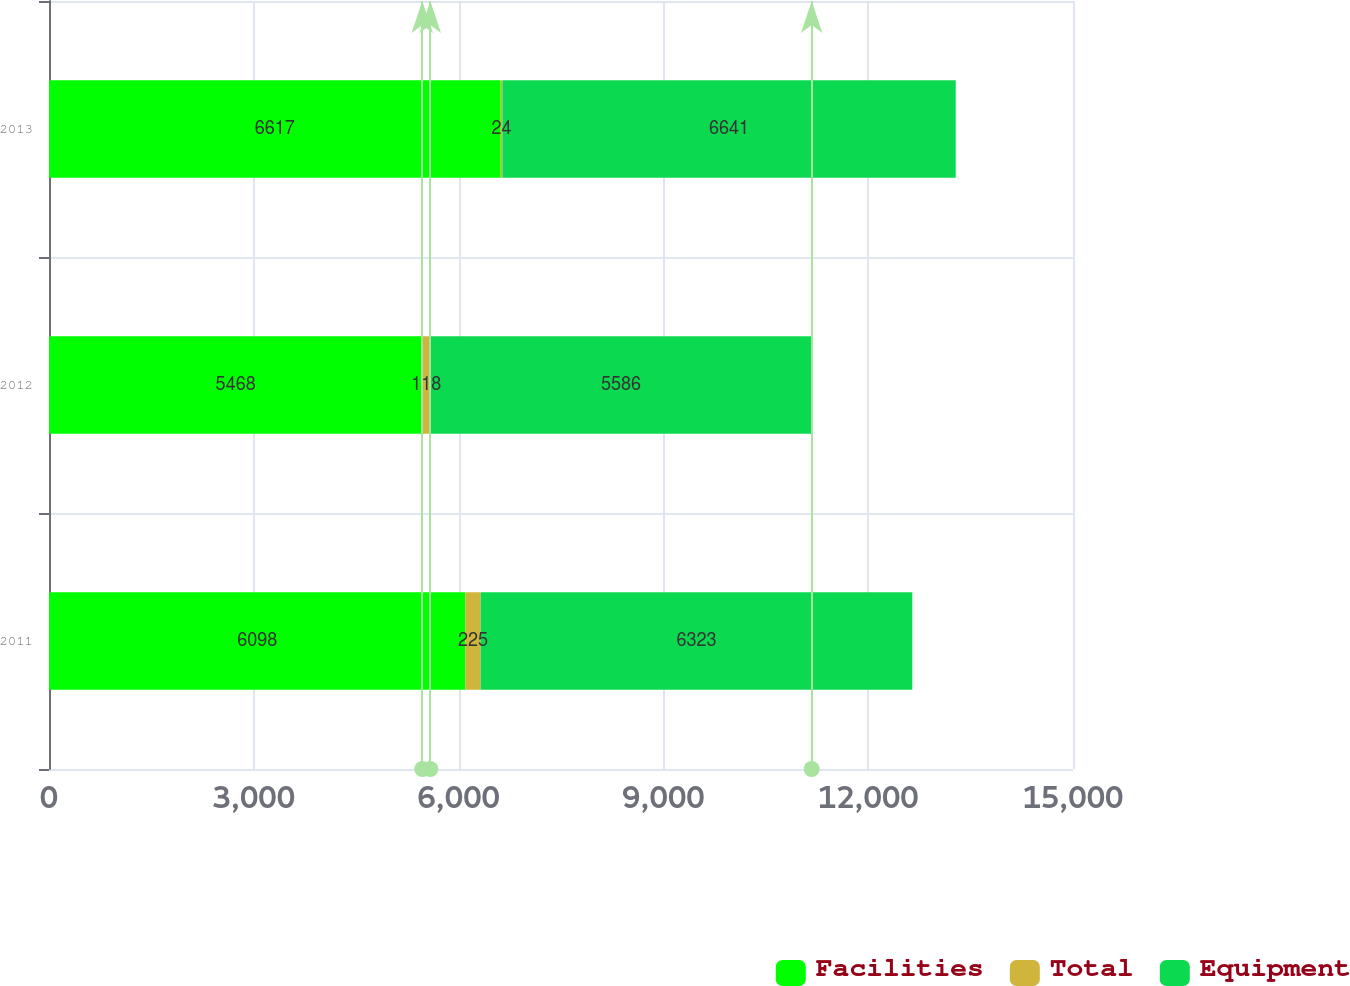Convert chart. <chart><loc_0><loc_0><loc_500><loc_500><stacked_bar_chart><ecel><fcel>2011<fcel>2012<fcel>2013<nl><fcel>Facilities<fcel>6098<fcel>5468<fcel>6617<nl><fcel>Total<fcel>225<fcel>118<fcel>24<nl><fcel>Equipment<fcel>6323<fcel>5586<fcel>6641<nl></chart> 